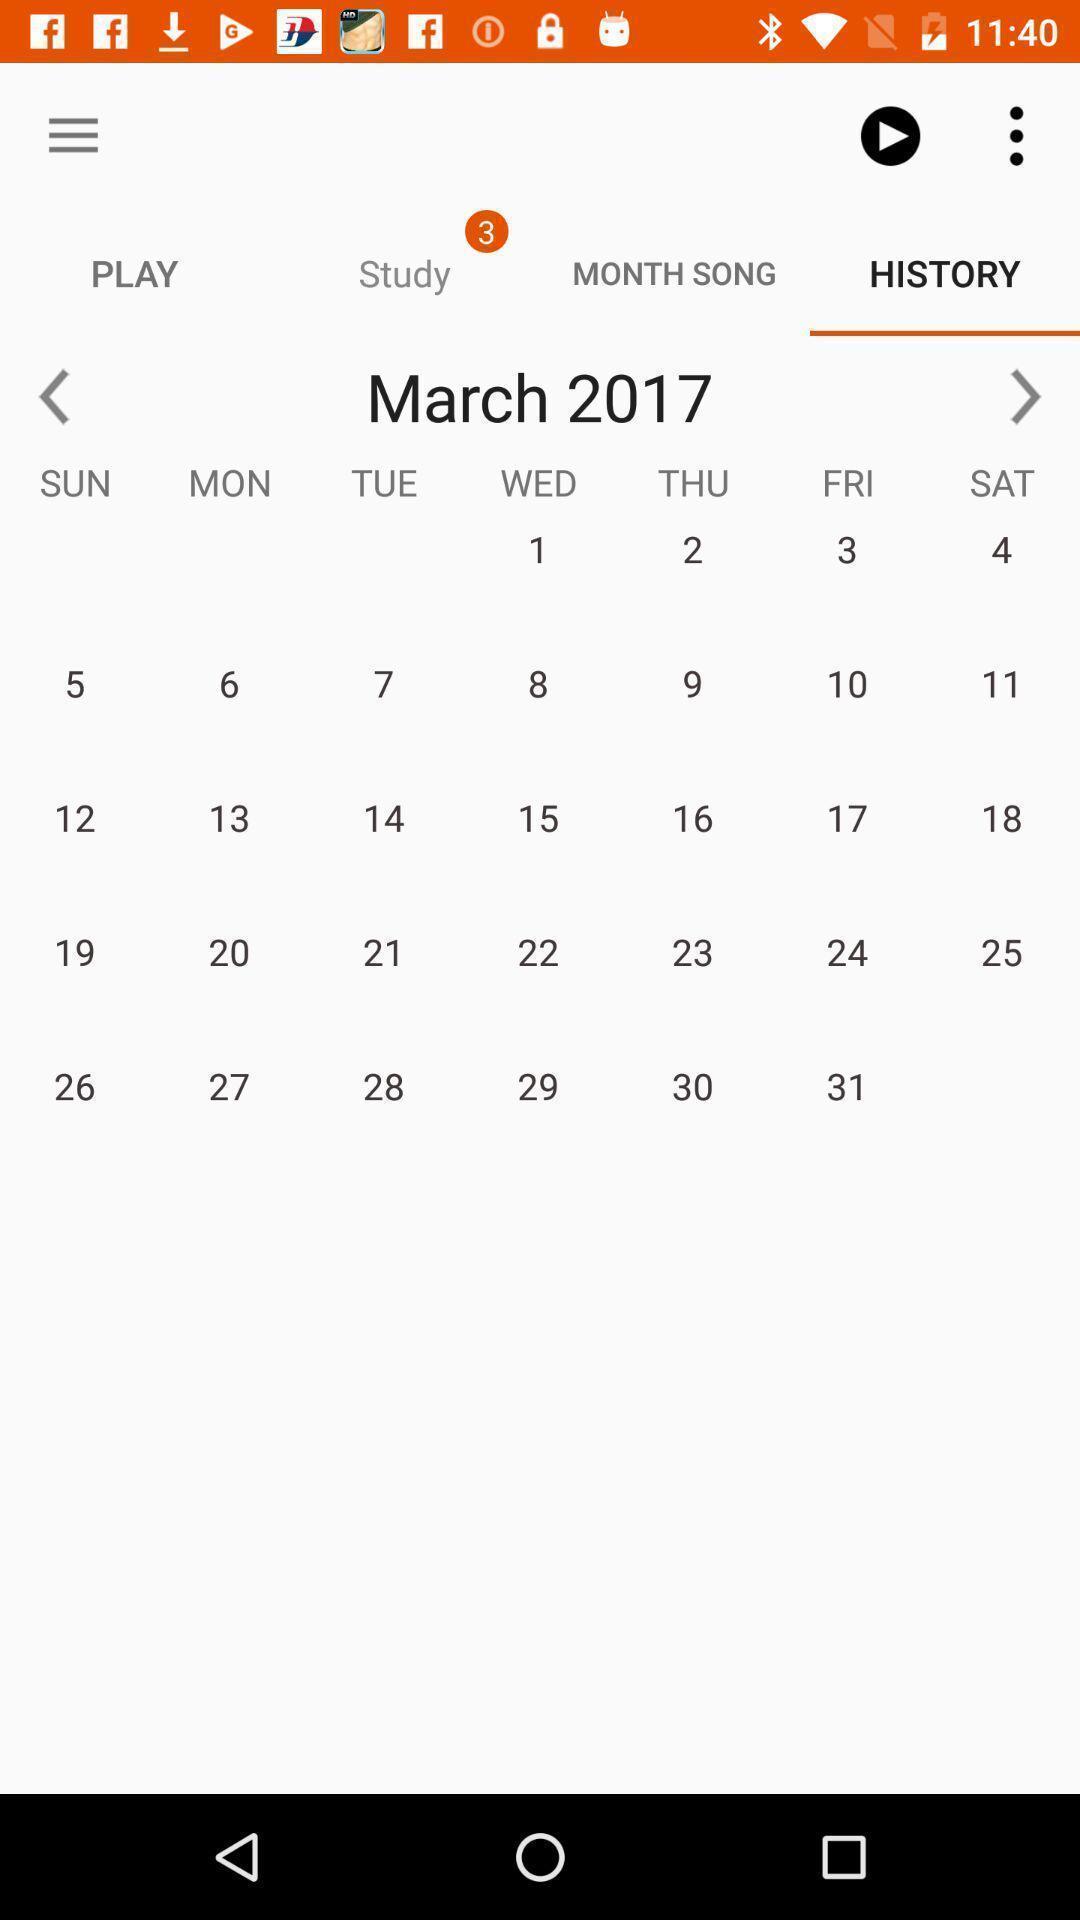Tell me about the visual elements in this screen capture. Screen displaying calendar. 